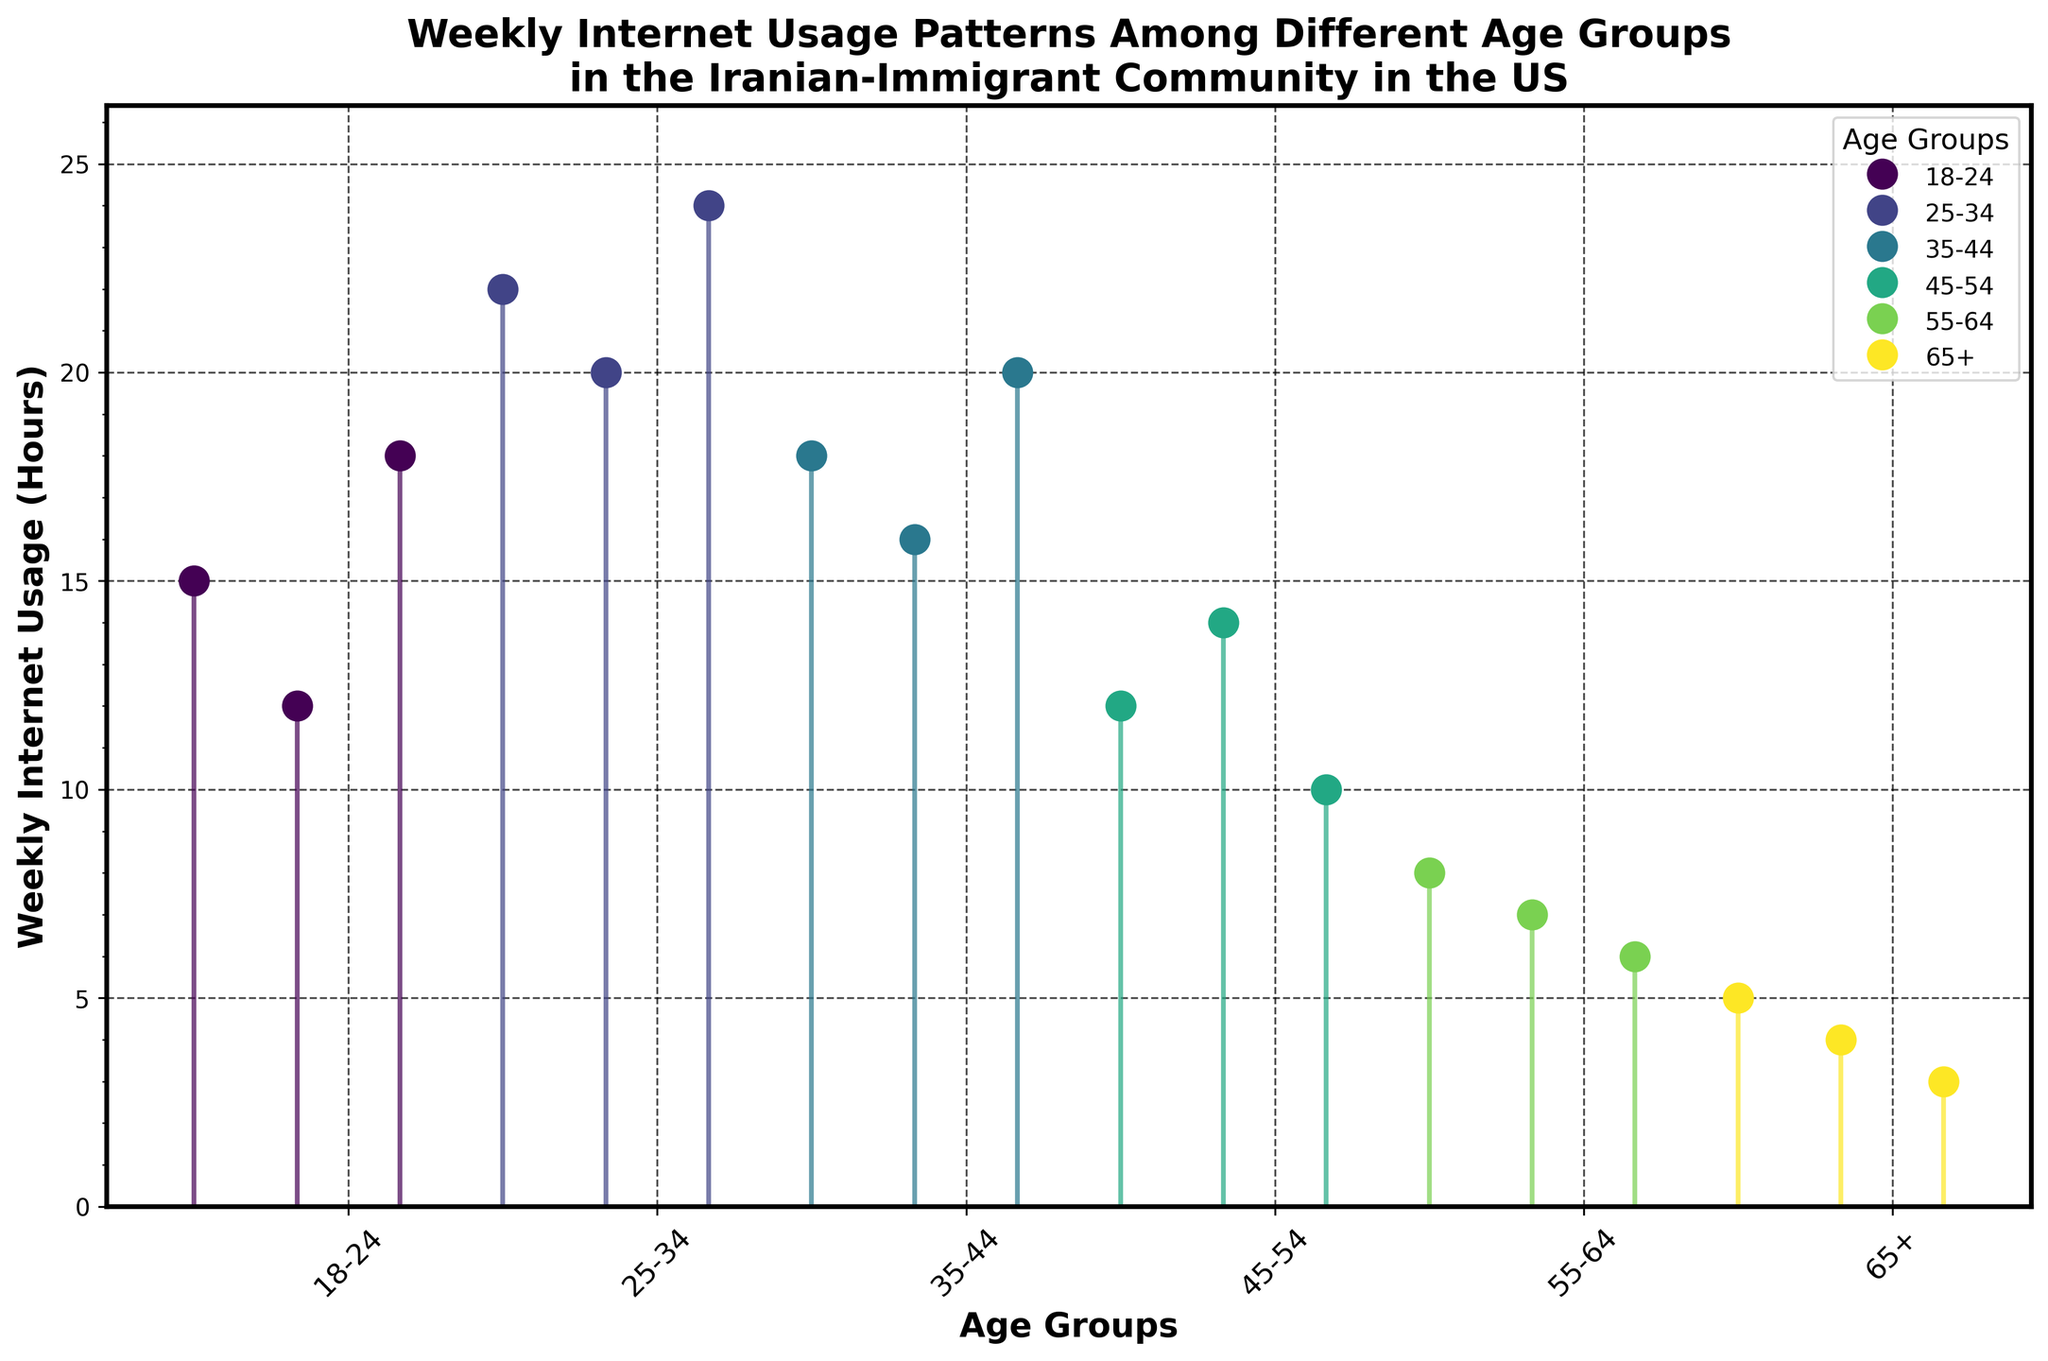What is the title of the figure? The title is placed at the top of the figure. It usually summarizes the main topic or focus.
Answer: Weekly Internet Usage Patterns Among Different Age Groups in the Iranian-Immigrant Community in the US How many unique age groups are presented in the figure? Count the number of distinct items on the x-axis labels. Each label corresponds to an age group.
Answer: 6 Which age group has the highest weekly internet usage hours depicted in the plot? Identify the data points with the highest values on the y-axis and note the corresponding age group label on the x-axis.
Answer: 25-34 What's the range of weekly internet usage hours for the 18-24 age group? Find the minimum and maximum values of the weekly internet usage hours for the specified age group. Then, determine the difference.
Answer: 6 hours (18 - 12) Which age group has the lowest weekly internet usage hours? Identify the lowest data points on the y-axis and note the corresponding age group label on the x-axis.
Answer: 65+ What is the most common weekly internet usage range (i.e., span of usage hours) observed in the 55-64 age group? Identify the minimum and maximum values within the specified age group and note any frequent values or ranges that appear.
Answer: 6-8 hours Between which two age groups is the difference in maximum weekly internet usage hours the greatest? Compare the maximum values of weekly internet usage hours across all age groups. Determine which two age groups have the biggest difference.
Answer: 25-34 and 65+ What are the weekly internet usage hours for the 45-54 age group? Look at the data points for the specified age group on the plot and identify the values.
Answer: 10, 12, 14 hours Is there any age group where all values are below 10 hours? Check each age group's data points to see if all the values are less than 10.
Answer: Yes, 65+ Which age group shows the highest variability in weekly internet usage hours? Observe the spread and range of the data points for each age group. Larger spreads indicate more variability.
Answer: 25-34 